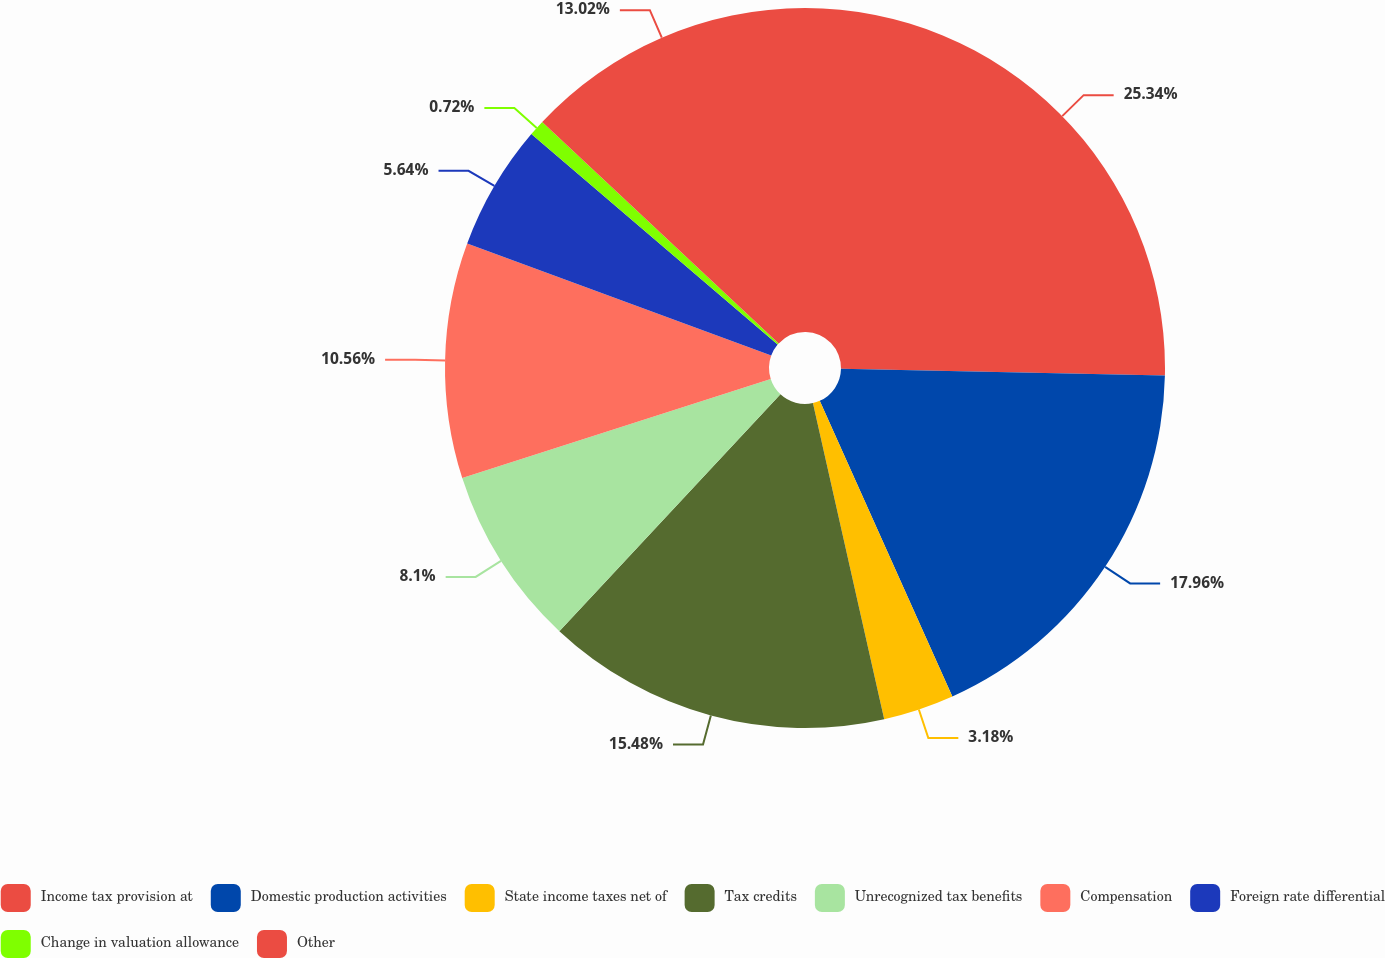<chart> <loc_0><loc_0><loc_500><loc_500><pie_chart><fcel>Income tax provision at<fcel>Domestic production activities<fcel>State income taxes net of<fcel>Tax credits<fcel>Unrecognized tax benefits<fcel>Compensation<fcel>Foreign rate differential<fcel>Change in valuation allowance<fcel>Other<nl><fcel>25.33%<fcel>17.95%<fcel>3.18%<fcel>15.48%<fcel>8.1%<fcel>10.56%<fcel>5.64%<fcel>0.72%<fcel>13.02%<nl></chart> 